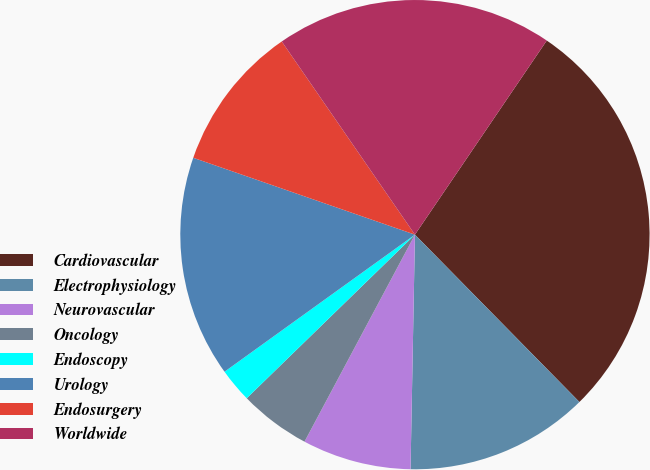Convert chart. <chart><loc_0><loc_0><loc_500><loc_500><pie_chart><fcel>Cardiovascular<fcel>Electrophysiology<fcel>Neurovascular<fcel>Oncology<fcel>Endoscopy<fcel>Urology<fcel>Endosurgery<fcel>Worldwide<nl><fcel>28.14%<fcel>12.66%<fcel>7.5%<fcel>4.92%<fcel>2.35%<fcel>15.24%<fcel>10.08%<fcel>19.1%<nl></chart> 